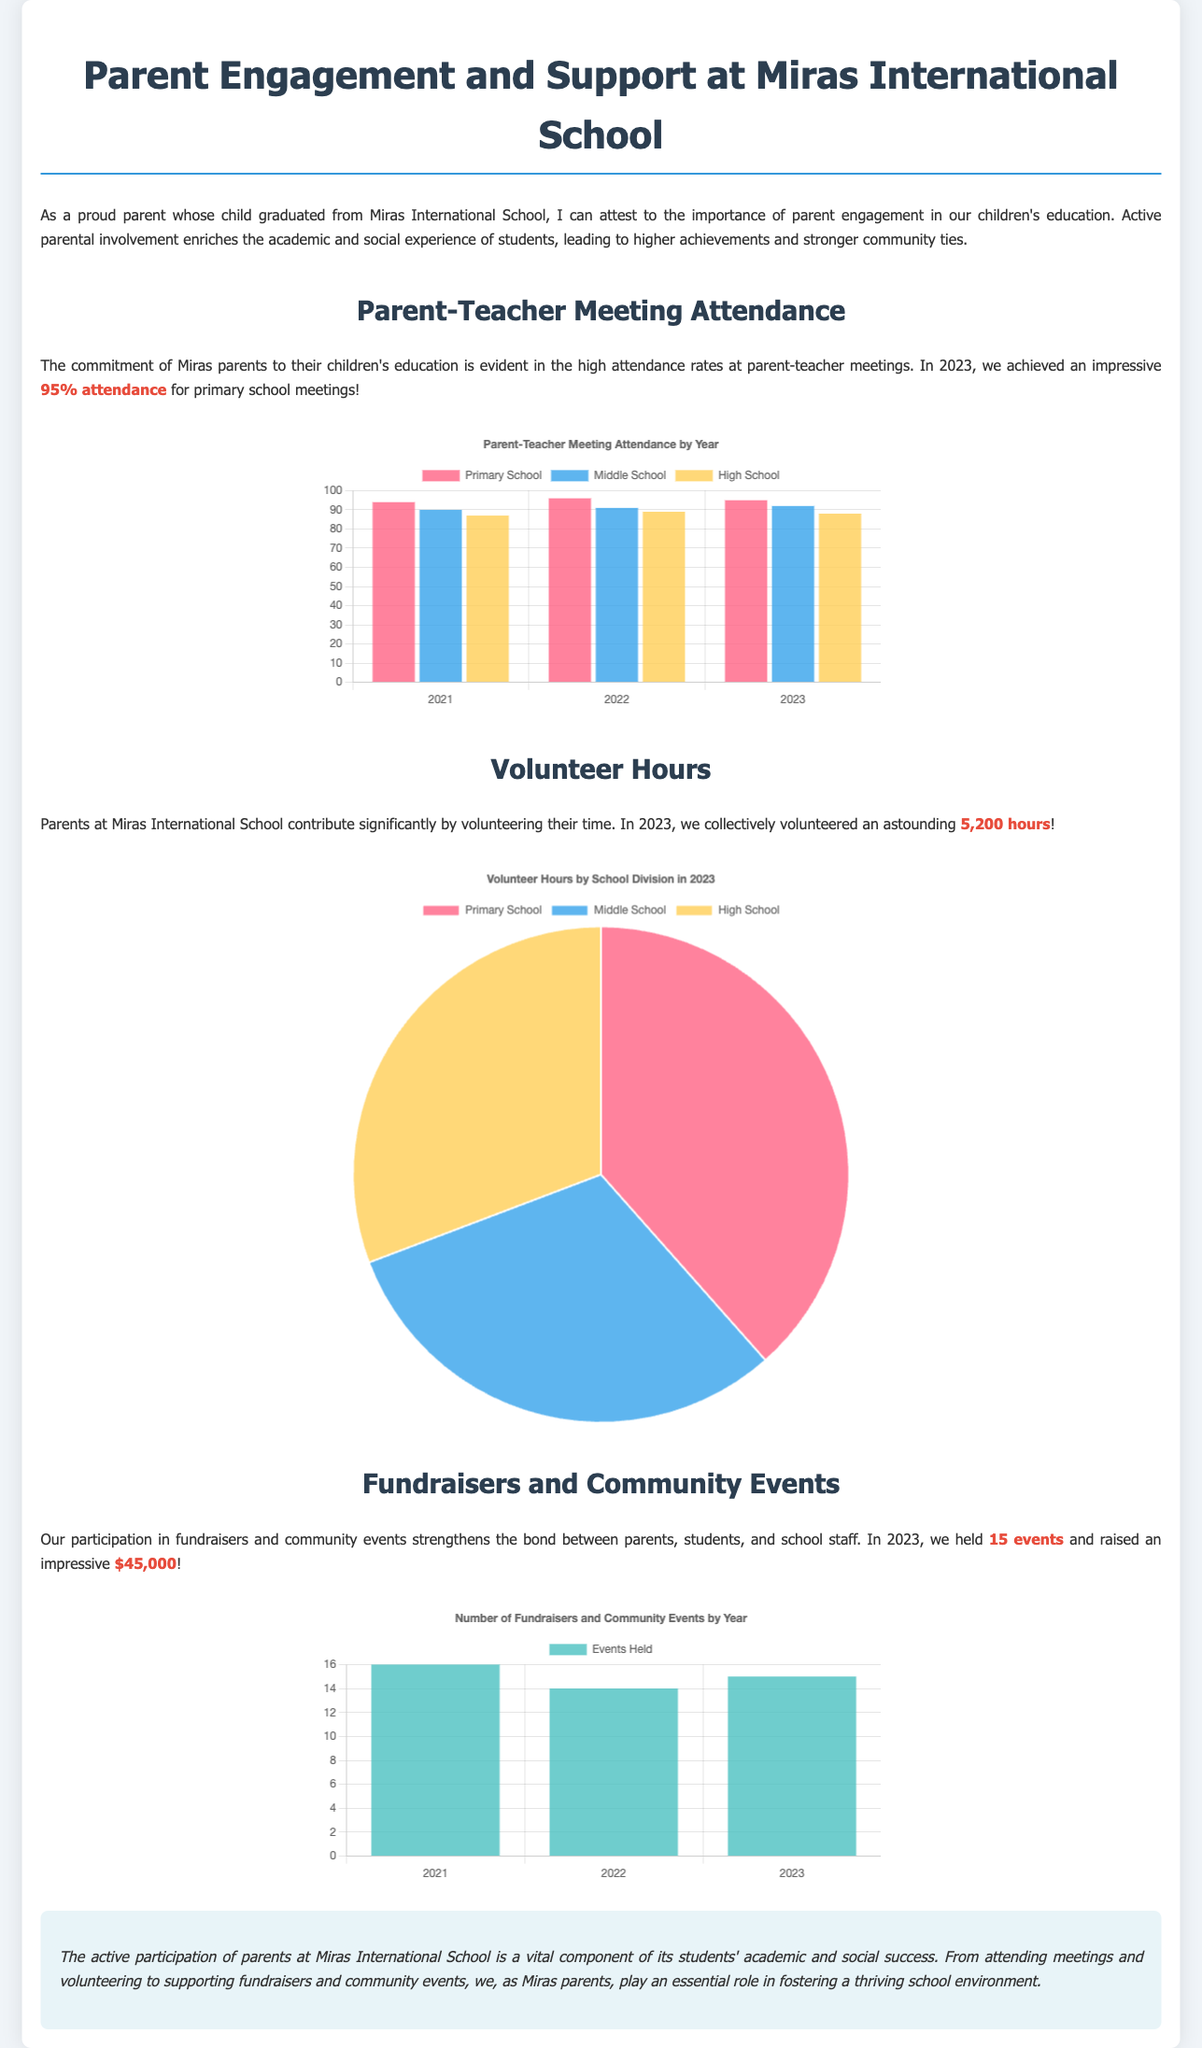what was the parent-teacher meeting attendance in 2023? The document states that the attendance for primary school meetings in 2023 was 95%.
Answer: 95% how many volunteer hours were contributed by parents in 2023? The document mentions that parents collectively volunteered an astounding 5,200 hours in 2023.
Answer: 5,200 hours how many events were held in 2023? The document states that 15 events were held in 2023.
Answer: 15 events what percentage of parents attended middle school meetings in 2022? The document provides information indicating that 91% of parents attended middle school meetings in 2022.
Answer: 91% how many total hours were volunteered by primary school parents? According to the document, primary school parents contributed 2,000 hours.
Answer: 2,000 hours what was the total amount raised from fundraisers in 2023? The document states that an impressive $45,000 was raised in 2023 from fundraisers.
Answer: $45,000 which school division received the most volunteer hours in 2023? The document indicates that primary school received the most volunteer hours, totaling 2,000 hours.
Answer: Primary School how many years does the attendance data cover in the chart? The attendance chart provides data for three years: 2021, 2022, and 2023.
Answer: Three years what type of chart is used to represent volunteer hours? The document describes a pie chart to represent volunteer hours by school division.
Answer: Pie chart 